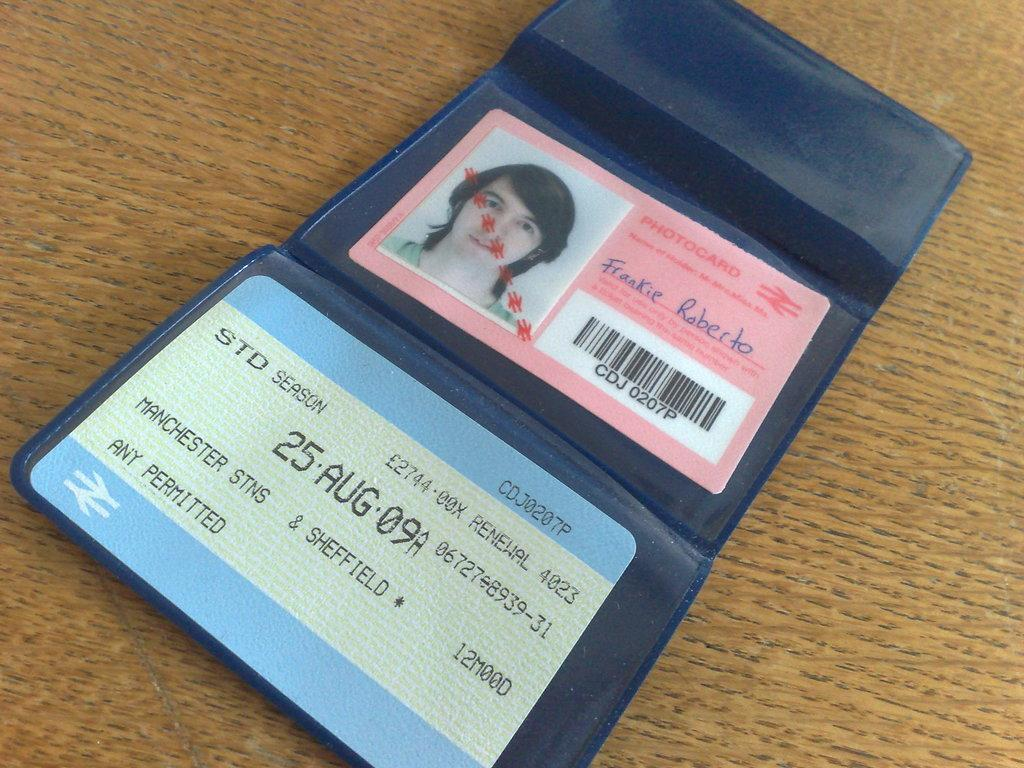What is the color of the purse in the image? The purse in the image is blue. What items are inside the purse? The purse contains two cards and a passport size photo. What is the surface on which the purse is placed? The purse is on a brown color surface. Are there any fairies visible in the image? No, there are no fairies present in the image. 